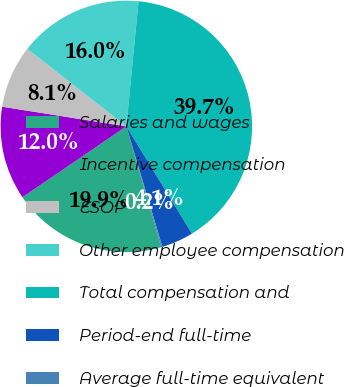Convert chart to OTSL. <chart><loc_0><loc_0><loc_500><loc_500><pie_chart><fcel>Salaries and wages<fcel>Incentive compensation<fcel>ESOP<fcel>Other employee compensation<fcel>Total compensation and<fcel>Period-end full-time<fcel>Average full-time equivalent<nl><fcel>19.94%<fcel>12.03%<fcel>8.07%<fcel>15.98%<fcel>39.72%<fcel>4.11%<fcel>0.16%<nl></chart> 